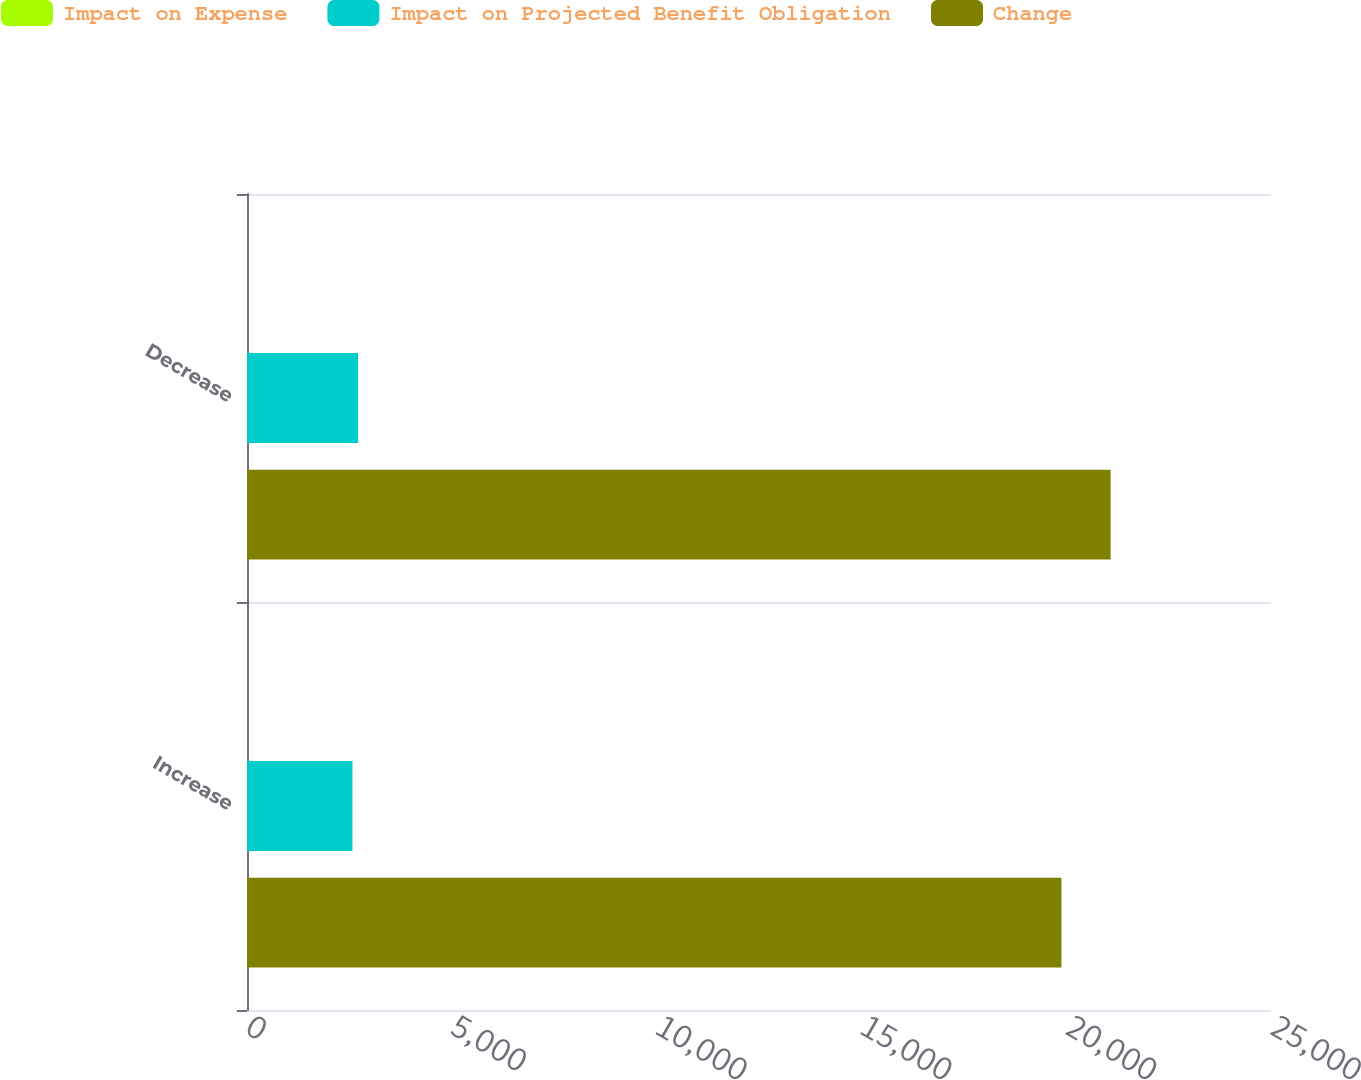<chart> <loc_0><loc_0><loc_500><loc_500><stacked_bar_chart><ecel><fcel>Increase<fcel>Decrease<nl><fcel>Impact on Expense<fcel>0.25<fcel>0.25<nl><fcel>Impact on Projected Benefit Obligation<fcel>2575<fcel>2712<nl><fcel>Change<fcel>19884<fcel>21084<nl></chart> 